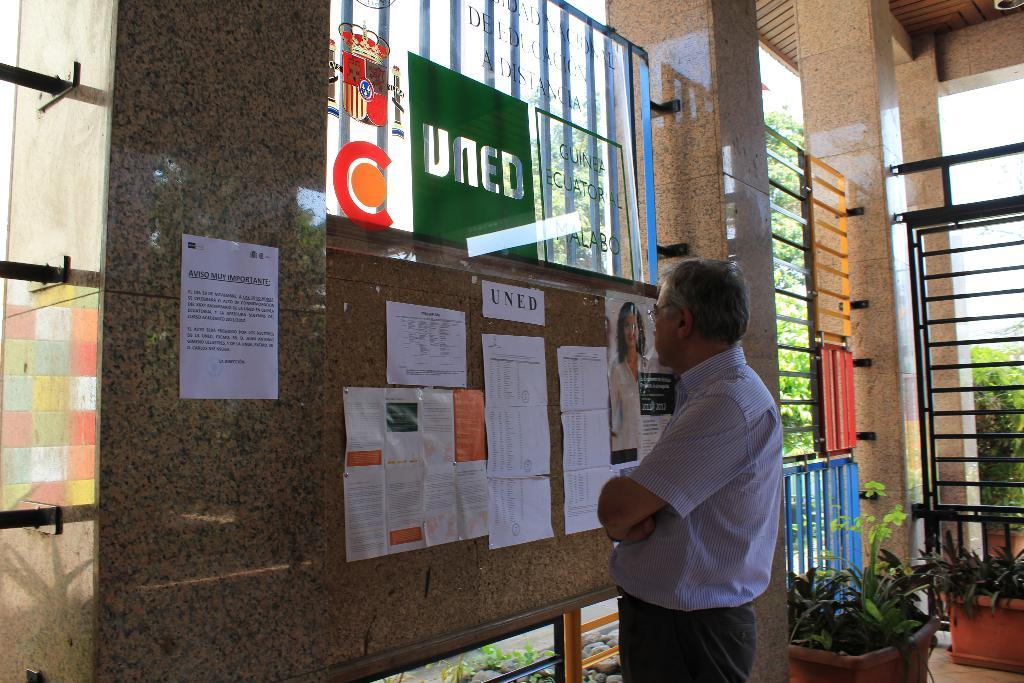Who is present in the image? There is a man in the image. What is the man wearing? The man is wearing spectacles. What is the man doing in the image? The man is standing and looking at posters on the wall. What type of vegetation can be seen in the image? There are house plants in the image. What architectural features are present in the image? There are pillars in the image. What type of natural elements are present in the image? There are stones and trees visible in the image. What type of honey can be seen dripping from the posters in the image? There is no honey present in the image; it features a man looking at posters on the wall. How many books are visible on the shelves in the image? There are no shelves or books visible in the image. 